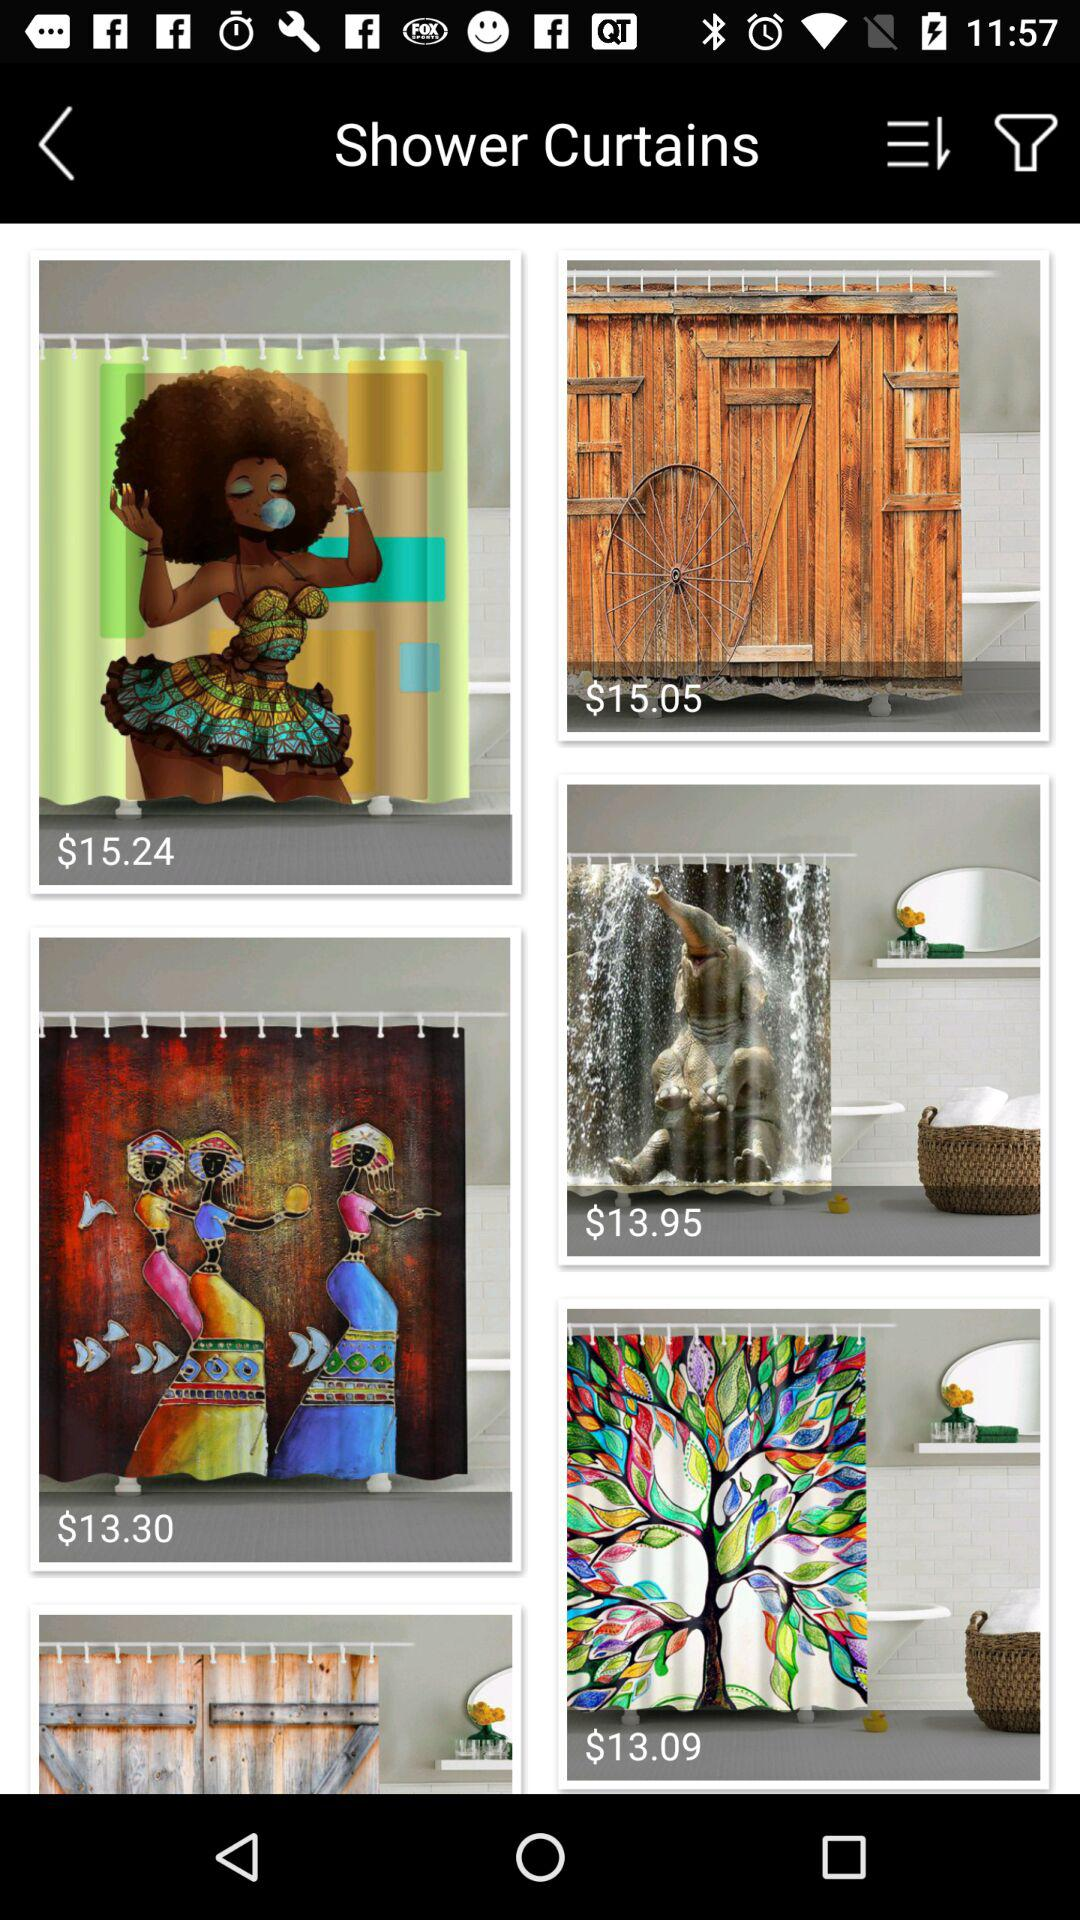How many shower curtains are priced under $15.00?
Answer the question using a single word or phrase. 3 